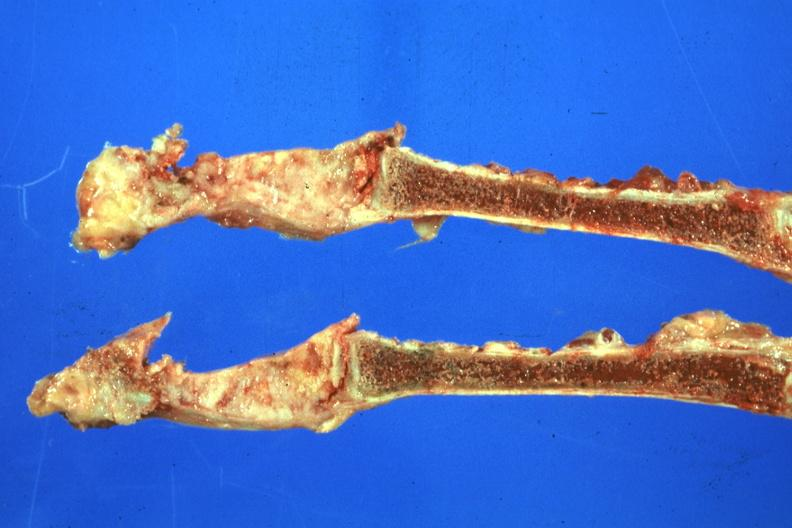s joints present?
Answer the question using a single word or phrase. Yes 